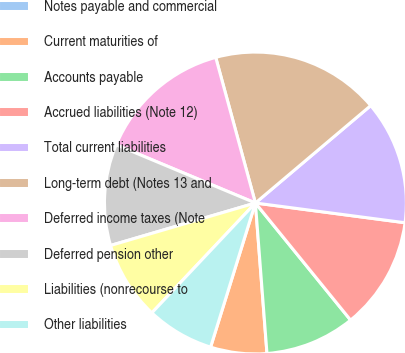Convert chart to OTSL. <chart><loc_0><loc_0><loc_500><loc_500><pie_chart><fcel>Notes payable and commercial<fcel>Current maturities of<fcel>Accounts payable<fcel>Accrued liabilities (Note 12)<fcel>Total current liabilities<fcel>Long-term debt (Notes 13 and<fcel>Deferred income taxes (Note<fcel>Deferred pension other<fcel>Liabilities (nonrecourse to<fcel>Other liabilities<nl><fcel>0.0%<fcel>6.02%<fcel>9.64%<fcel>12.05%<fcel>13.25%<fcel>18.07%<fcel>14.46%<fcel>10.84%<fcel>8.43%<fcel>7.23%<nl></chart> 